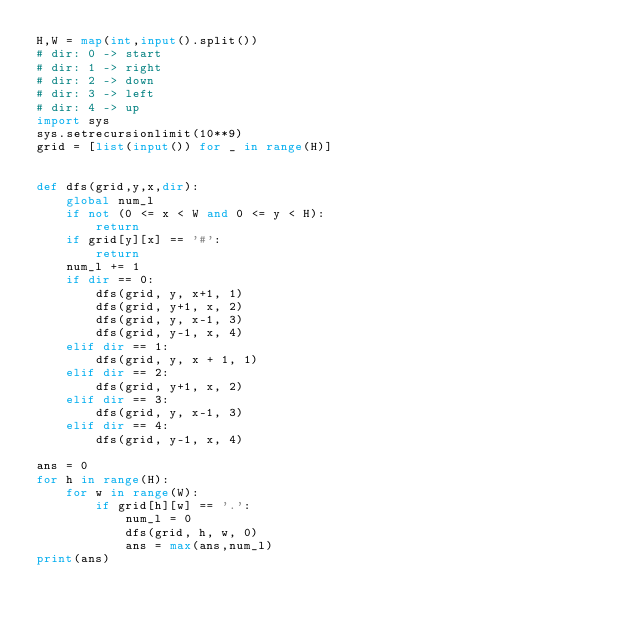Convert code to text. <code><loc_0><loc_0><loc_500><loc_500><_Python_>H,W = map(int,input().split())
# dir: 0 -> start
# dir: 1 -> right
# dir: 2 -> down
# dir: 3 -> left
# dir: 4 -> up
import sys
sys.setrecursionlimit(10**9)
grid = [list(input()) for _ in range(H)]


def dfs(grid,y,x,dir):
    global num_l
    if not (0 <= x < W and 0 <= y < H):
        return
    if grid[y][x] == '#':
        return
    num_l += 1
    if dir == 0:
        dfs(grid, y, x+1, 1)
        dfs(grid, y+1, x, 2)
        dfs(grid, y, x-1, 3)
        dfs(grid, y-1, x, 4)
    elif dir == 1:
        dfs(grid, y, x + 1, 1)
    elif dir == 2:
        dfs(grid, y+1, x, 2)
    elif dir == 3:
        dfs(grid, y, x-1, 3)
    elif dir == 4:
        dfs(grid, y-1, x, 4)

ans = 0
for h in range(H):
    for w in range(W):
        if grid[h][w] == '.':
            num_l = 0
            dfs(grid, h, w, 0)
            ans = max(ans,num_l)
print(ans)</code> 